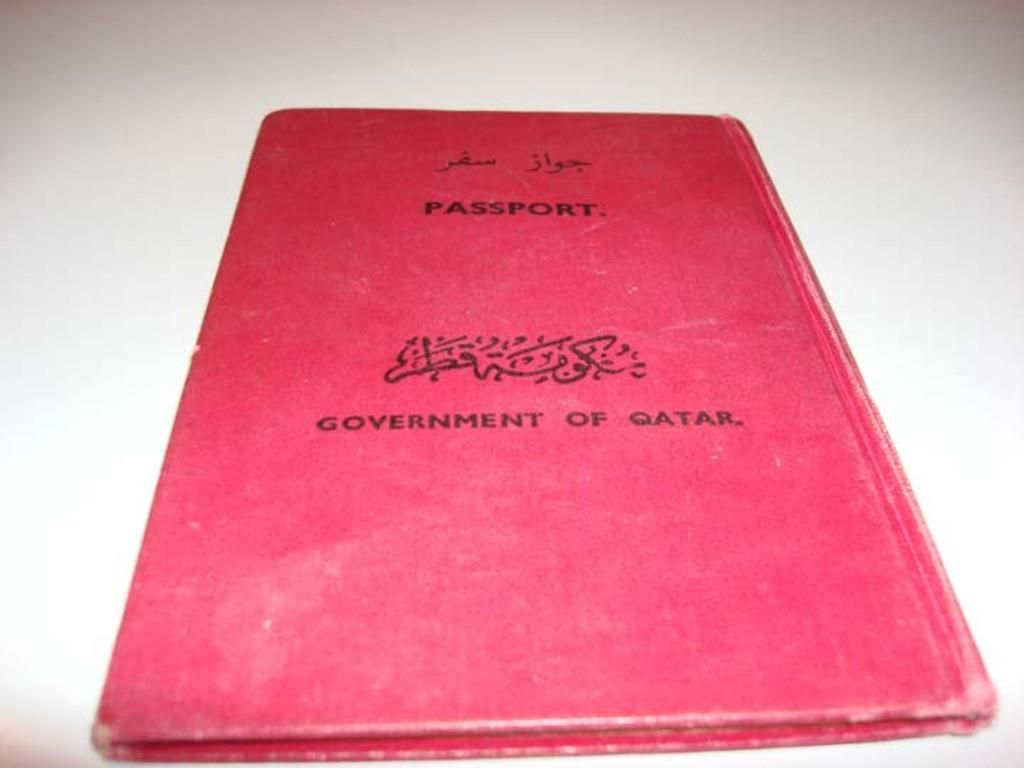<image>
Offer a succinct explanation of the picture presented. Red passport sits alone on a white table 